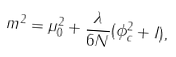<formula> <loc_0><loc_0><loc_500><loc_500>m ^ { 2 } = \mu _ { 0 } ^ { 2 } + \frac { \lambda } { 6 N } ( \phi _ { c } ^ { 2 } + I ) ,</formula> 